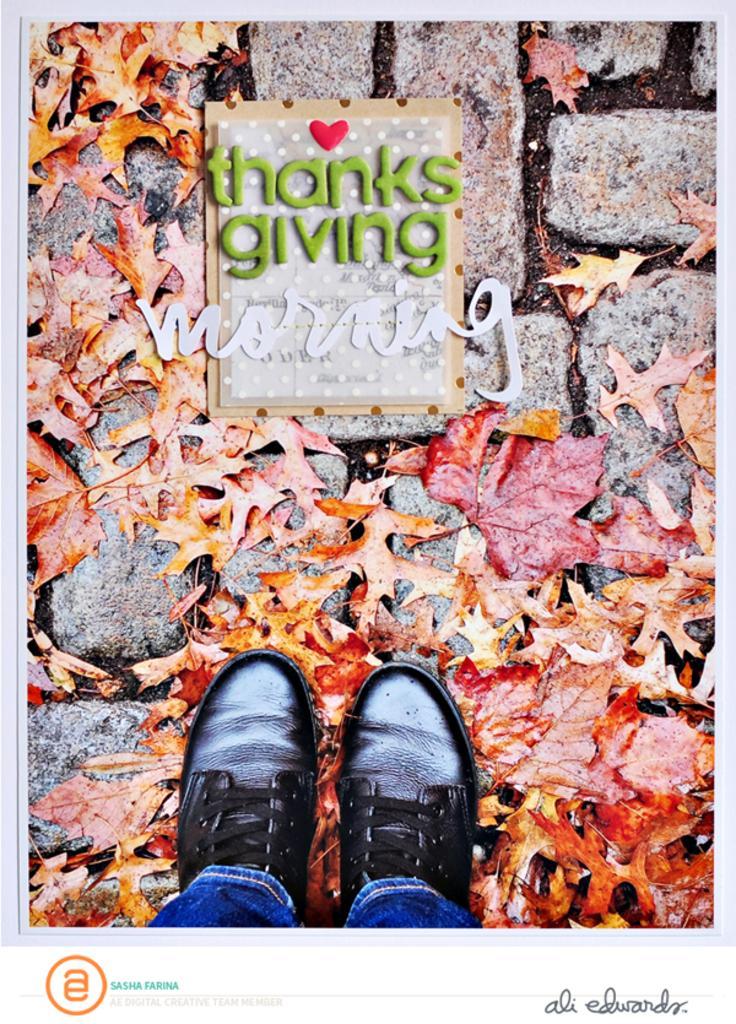Can you describe this image briefly? In this image we can see poster. On the poster there is text. Also there is a floor with bricks. On that there are leaves. Also we can see legs of person with shoes. At the bottom there is text and a logo. 